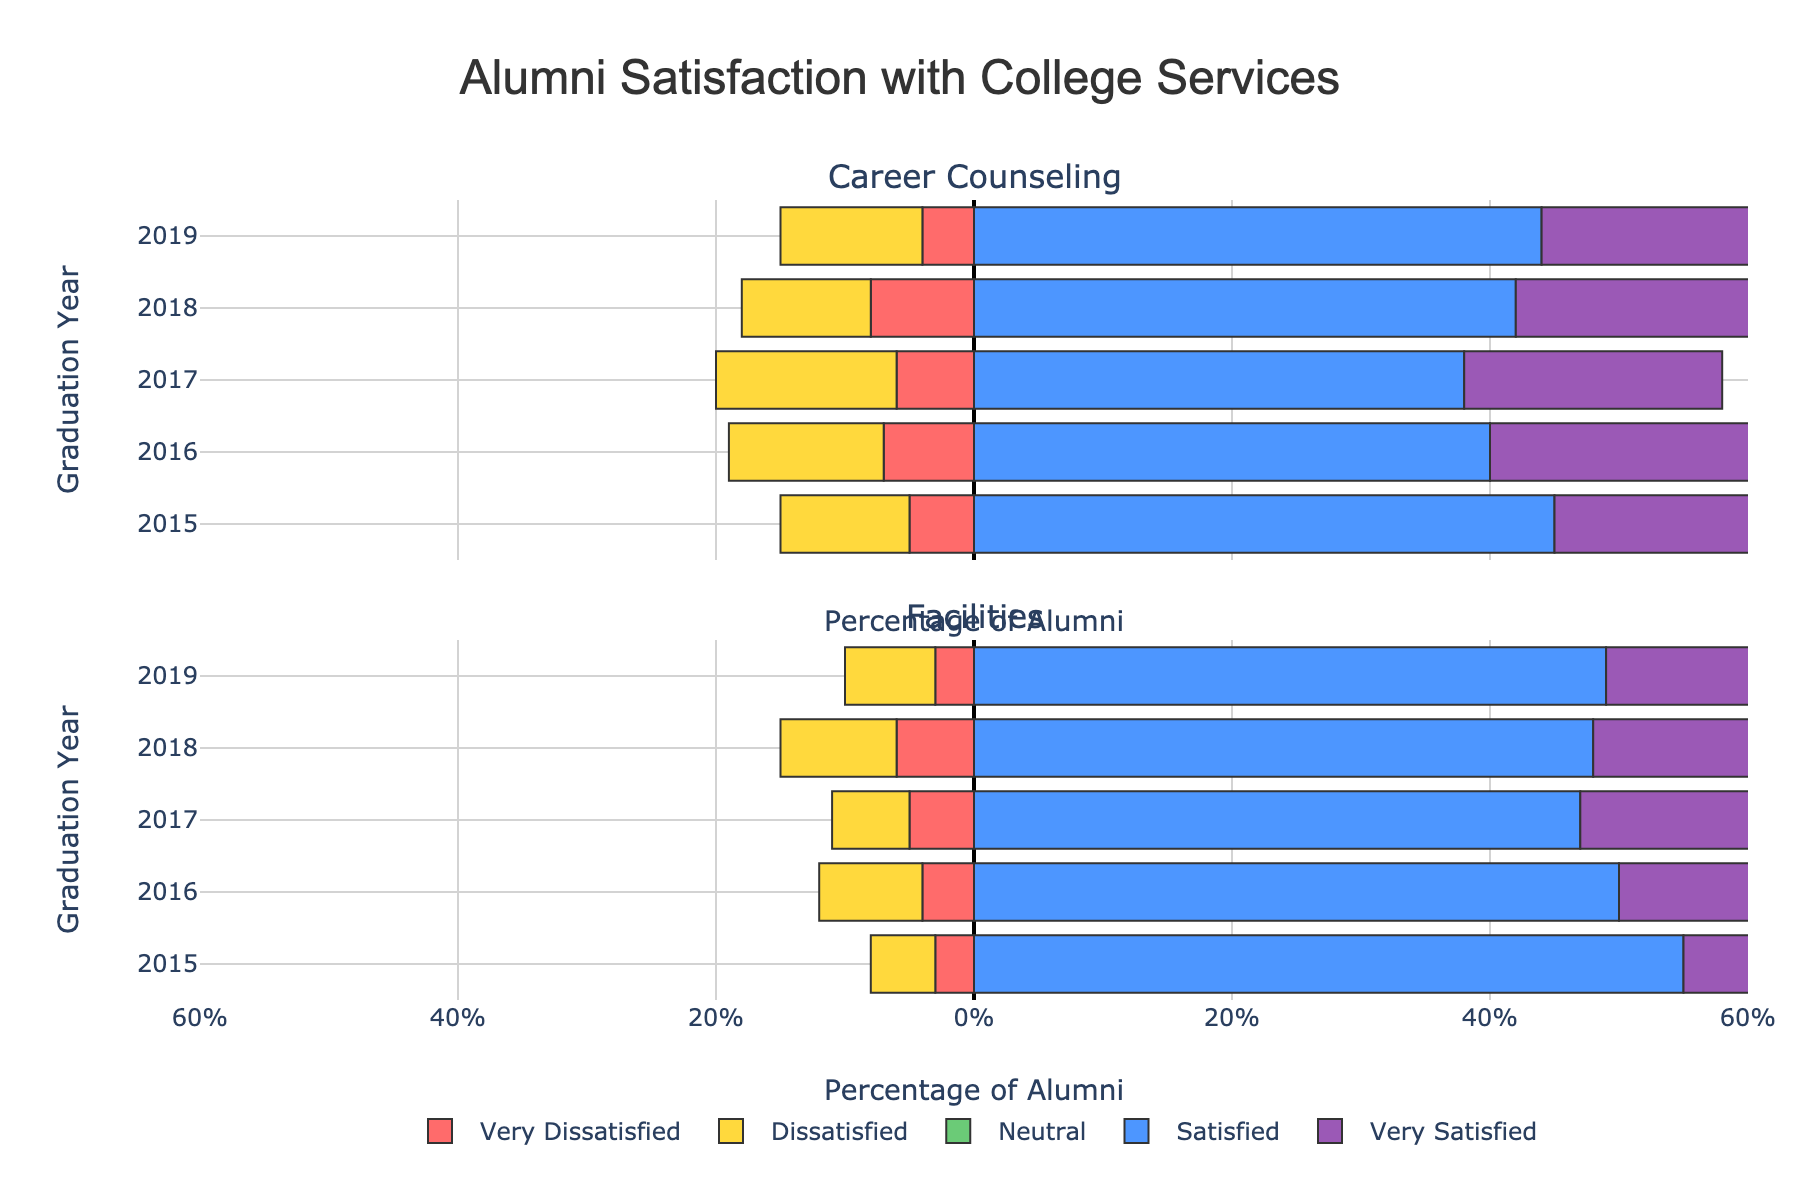What is the overall satisfaction trend for career counseling from 2015 to 2019? To determine the trend, note the percentages of "satisfied" and "very satisfied" alumni for each year, and observe whether these values increase, decrease, or remain stable. For career counseling from 2015 to 2019, the percentages remain relatively stable but with slight variations.
Answer: Relatively stable Which graduation year had the highest percentage of alumni dissatisfied with facilities? Compare the heights of the bars representing "dissatisfied" alumni for facilities across all years. The bar for 2016 is the tallest one in this category.
Answer: 2016 How does the neutral satisfaction level for career counseling in 2017 compare to that in 2018? Compare the lengths of the neutral (grey) bars in the career counseling subplot for 2017 and 2018. The neutral satisfaction level is higher in 2017 than in 2018.
Answer: Higher in 2017 What is the total percentage of alumni satisfied or very satisfied with facilities in 2019? Add the percentages of "satisfied" (49%) and "very satisfied" (25%) for facilities in 2019.
Answer: 74% Did the percentage of very dissatisfied alumni with career counseling increase or decrease from 2015 to 2018? Compare the heights of the "very dissatisfied" (red) bars for career counseling between 2015 and 2018. The value increases from 5% in 2015 to 8% in 2018.
Answer: Increase Which service has a consistently higher satisfaction level over the years: career counseling or facilities? Compare the overall lengths of the positive ("satisfied" and "very satisfied") bars for both services. Facilities tend to have higher satisfaction levels than career counseling.
Answer: Facilities In which year did facilities have the lowest satisfaction levels? Combine "very dissatisfied", "dissatisfied", and "neutral" categories and compare across the years. Facilities have the lowest satisfaction in 2017.
Answer: 2017 What is the difference in the percentage of alumni satisfied with facilities between 2015 and 2016? Subtract the "satisfied" percentage of alumni for facilities in 2015 (55%) from that in 2016 (50%).
Answer: 5% For which year and service is the percentage of alumni reporting neutral satisfaction the highest? Identify the longest "neutral" (grey) bar across all years and services. For career counseling in 2017, the neutral satisfaction is the highest at 22%.
Answer: Career counseling, 2017 Does the percentage of very satisfied alumni with facilities increase, decrease, or remain stable from 2015 to 2019? Examine the heights of the "very satisfied" (purple) bars for facilities from 2015 to 2019. The percentage remains relatively stable with minor fluctuations.
Answer: Relatively stable 